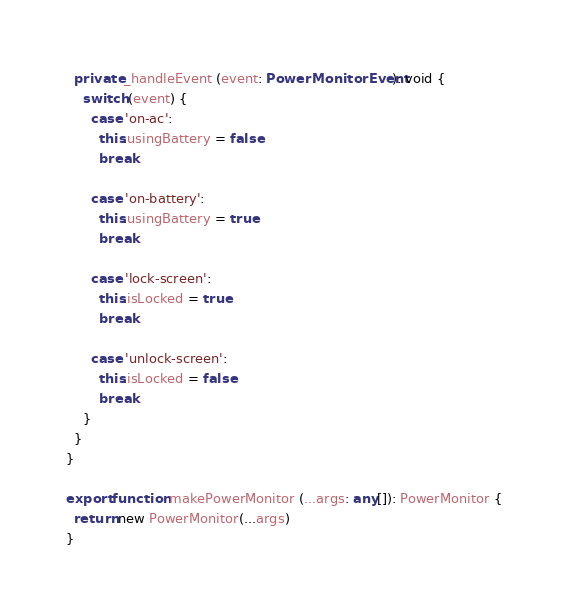Convert code to text. <code><loc_0><loc_0><loc_500><loc_500><_TypeScript_>  private _handleEvent (event: PowerMonitorEvent): void {
    switch (event) {
      case 'on-ac':
        this.usingBattery = false
        break

      case 'on-battery':
        this.usingBattery = true
        break

      case 'lock-screen':
        this.isLocked = true
        break

      case 'unlock-screen':
        this.isLocked = false
        break
    }
  }
}

export function makePowerMonitor (...args: any[]): PowerMonitor {
  return new PowerMonitor(...args)
}
</code> 